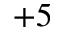<formula> <loc_0><loc_0><loc_500><loc_500>+ 5</formula> 